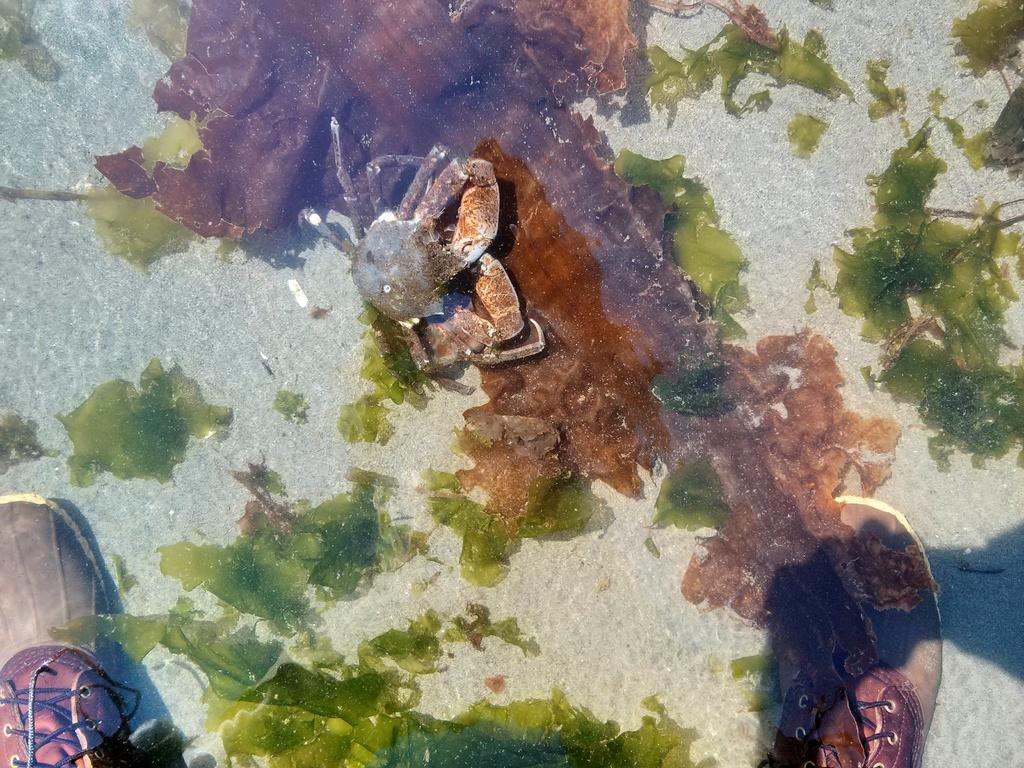What type of animal can be seen in the image? There is a crab in the image. What other objects or living organisms are present in the image? There is a group of plants in the image. Can you describe any human presence in the image? The legs of a person wearing shoes are visible in the image. What type of approval is the person giving to the dolls in the image? There are no dolls present in the image, so it is not possible to determine if the person is giving any approval. 